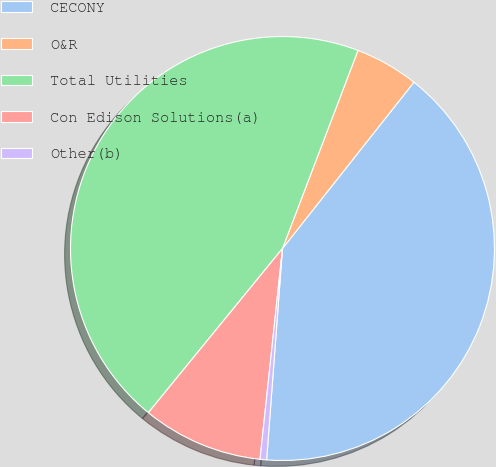Convert chart. <chart><loc_0><loc_0><loc_500><loc_500><pie_chart><fcel>CECONY<fcel>O&R<fcel>Total Utilities<fcel>Con Edison Solutions(a)<fcel>Other(b)<nl><fcel>40.54%<fcel>4.85%<fcel>44.89%<fcel>9.21%<fcel>0.5%<nl></chart> 